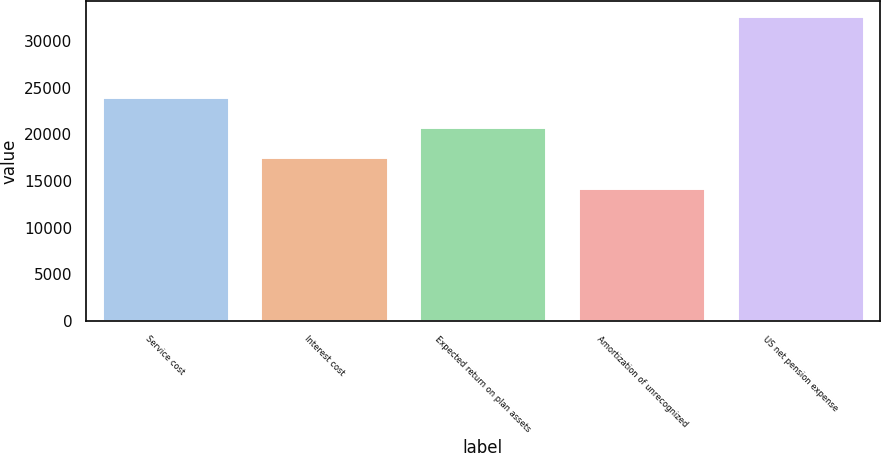<chart> <loc_0><loc_0><loc_500><loc_500><bar_chart><fcel>Service cost<fcel>Interest cost<fcel>Expected return on plan assets<fcel>Amortization of unrecognized<fcel>US net pension expense<nl><fcel>24051<fcel>17537<fcel>20794<fcel>14280<fcel>32657<nl></chart> 